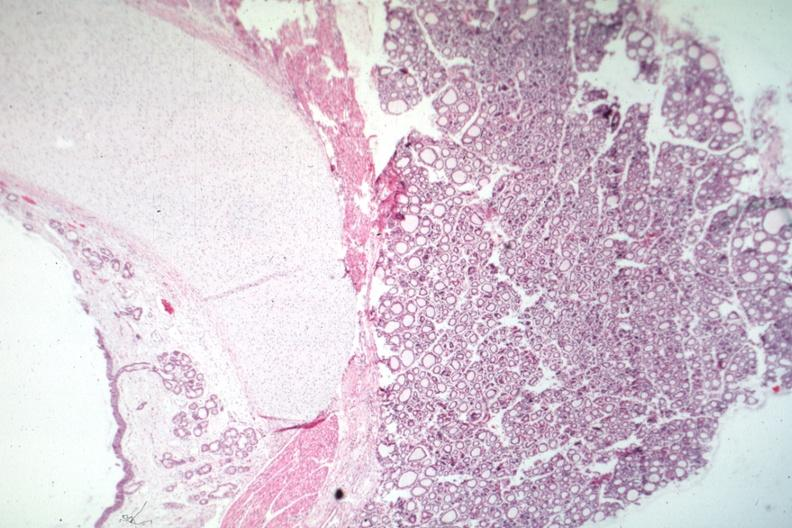s endocrine present?
Answer the question using a single word or phrase. Yes 